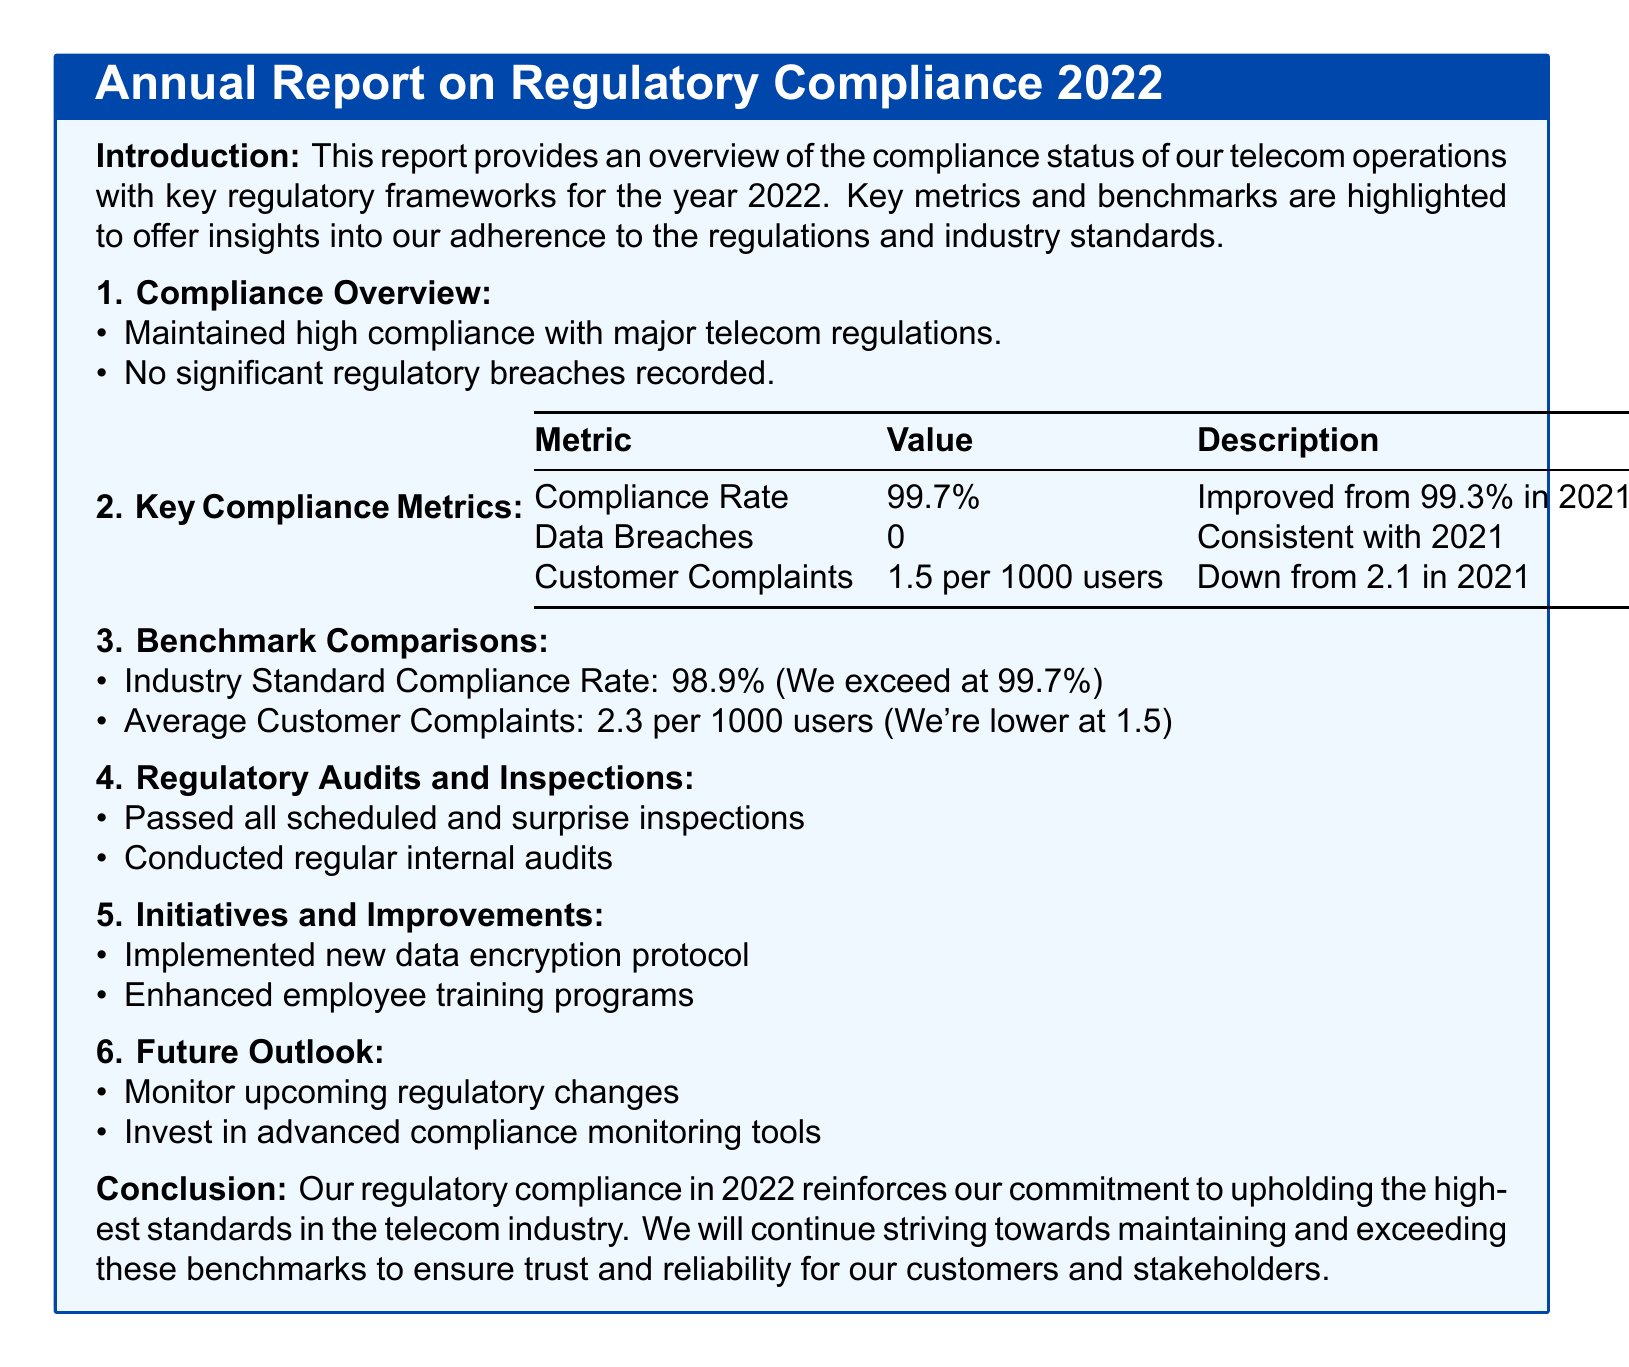What was the compliance rate in 2022? The compliance rate is a key metric mentioned in the document for the year 2022, which is 99.7%.
Answer: 99.7% How many data breaches were recorded in 2022? The report states that the number of data breaches in 2022 was zero, consistent with the previous year.
Answer: 0 What was the customer complaint rate per 1000 users in 2022? The customer complaints metric lists the rate for 2022 as 1.5 per 1000 users, which indicates an improvement from 2021.
Answer: 1.5 per 1000 users What was the industry standard compliance rate? The benchmark comparison section presents the industry standard compliance rate, which is 98.9%.
Answer: 98.9% What initiatives were implemented in 2022? The section on initiatives and improvements mentions new data encryption protocols as one of the changes made in 2022.
Answer: New data encryption protocol What is the purpose of the report? The introduction of the report states that its purpose is to provide an overview of compliance status with key regulatory frameworks for 2022.
Answer: Compliance overview Which year did the compliance rate improve from 99.3%? The document indicates that the compliance rate improved from 99.3% in 2021 to 99.7% in 2022.
Answer: 2021 What future outlooks are mentioned for compliance? The report suggests monitoring upcoming regulatory changes as part of its future outlooks regarding compliance.
Answer: Monitor upcoming regulatory changes How many audits and inspections were passed? The document confirms that all scheduled and surprise inspections were passed in the regulatory audits section.
Answer: All scheduled and surprise inspections 